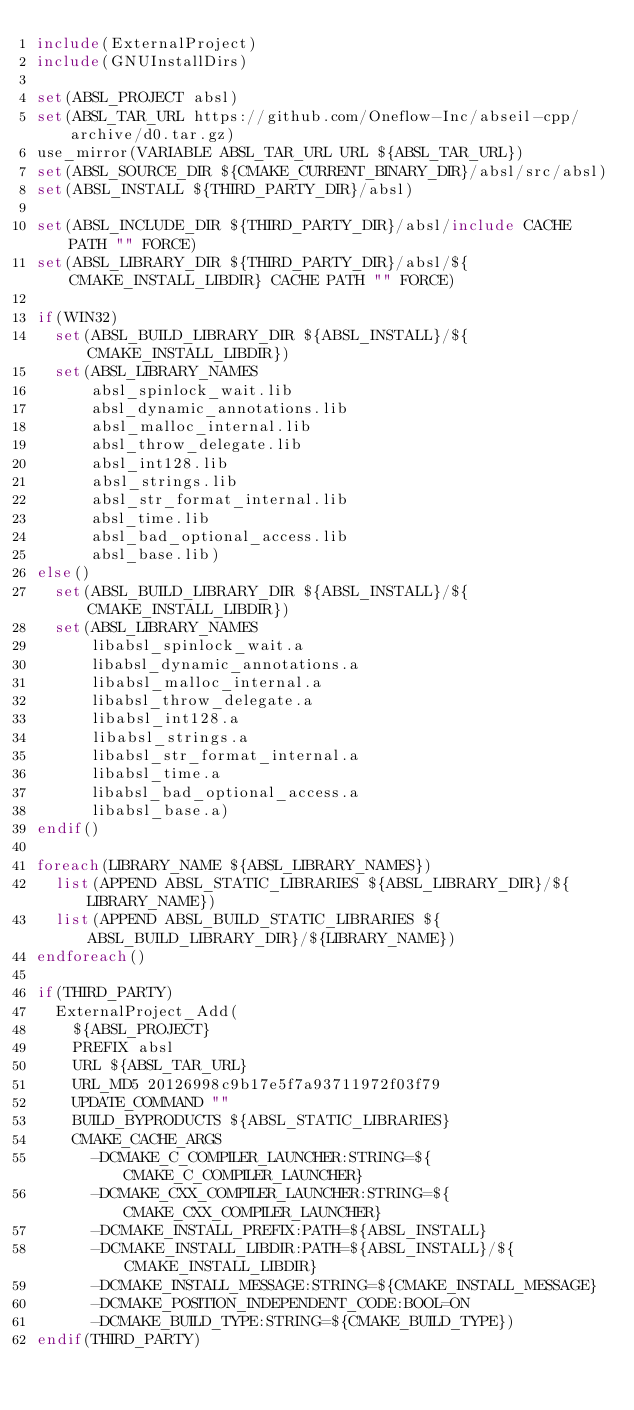Convert code to text. <code><loc_0><loc_0><loc_500><loc_500><_CMake_>include(ExternalProject)
include(GNUInstallDirs)

set(ABSL_PROJECT absl)
set(ABSL_TAR_URL https://github.com/Oneflow-Inc/abseil-cpp/archive/d0.tar.gz)
use_mirror(VARIABLE ABSL_TAR_URL URL ${ABSL_TAR_URL})
set(ABSL_SOURCE_DIR ${CMAKE_CURRENT_BINARY_DIR}/absl/src/absl)
set(ABSL_INSTALL ${THIRD_PARTY_DIR}/absl)

set(ABSL_INCLUDE_DIR ${THIRD_PARTY_DIR}/absl/include CACHE PATH "" FORCE)
set(ABSL_LIBRARY_DIR ${THIRD_PARTY_DIR}/absl/${CMAKE_INSTALL_LIBDIR} CACHE PATH "" FORCE)

if(WIN32)
  set(ABSL_BUILD_LIBRARY_DIR ${ABSL_INSTALL}/${CMAKE_INSTALL_LIBDIR})
  set(ABSL_LIBRARY_NAMES
      absl_spinlock_wait.lib
      absl_dynamic_annotations.lib
      absl_malloc_internal.lib
      absl_throw_delegate.lib
      absl_int128.lib
      absl_strings.lib
      absl_str_format_internal.lib
      absl_time.lib
      absl_bad_optional_access.lib
      absl_base.lib)
else()
  set(ABSL_BUILD_LIBRARY_DIR ${ABSL_INSTALL}/${CMAKE_INSTALL_LIBDIR})
  set(ABSL_LIBRARY_NAMES
      libabsl_spinlock_wait.a
      libabsl_dynamic_annotations.a
      libabsl_malloc_internal.a
      libabsl_throw_delegate.a
      libabsl_int128.a
      libabsl_strings.a
      libabsl_str_format_internal.a
      libabsl_time.a
      libabsl_bad_optional_access.a
      libabsl_base.a)
endif()

foreach(LIBRARY_NAME ${ABSL_LIBRARY_NAMES})
  list(APPEND ABSL_STATIC_LIBRARIES ${ABSL_LIBRARY_DIR}/${LIBRARY_NAME})
  list(APPEND ABSL_BUILD_STATIC_LIBRARIES ${ABSL_BUILD_LIBRARY_DIR}/${LIBRARY_NAME})
endforeach()

if(THIRD_PARTY)
  ExternalProject_Add(
    ${ABSL_PROJECT}
    PREFIX absl
    URL ${ABSL_TAR_URL}
    URL_MD5 20126998c9b17e5f7a93711972f03f79
    UPDATE_COMMAND ""
    BUILD_BYPRODUCTS ${ABSL_STATIC_LIBRARIES}
    CMAKE_CACHE_ARGS
      -DCMAKE_C_COMPILER_LAUNCHER:STRING=${CMAKE_C_COMPILER_LAUNCHER}
      -DCMAKE_CXX_COMPILER_LAUNCHER:STRING=${CMAKE_CXX_COMPILER_LAUNCHER}
      -DCMAKE_INSTALL_PREFIX:PATH=${ABSL_INSTALL}
      -DCMAKE_INSTALL_LIBDIR:PATH=${ABSL_INSTALL}/${CMAKE_INSTALL_LIBDIR}
      -DCMAKE_INSTALL_MESSAGE:STRING=${CMAKE_INSTALL_MESSAGE}
      -DCMAKE_POSITION_INDEPENDENT_CODE:BOOL=ON
      -DCMAKE_BUILD_TYPE:STRING=${CMAKE_BUILD_TYPE})
endif(THIRD_PARTY)
</code> 